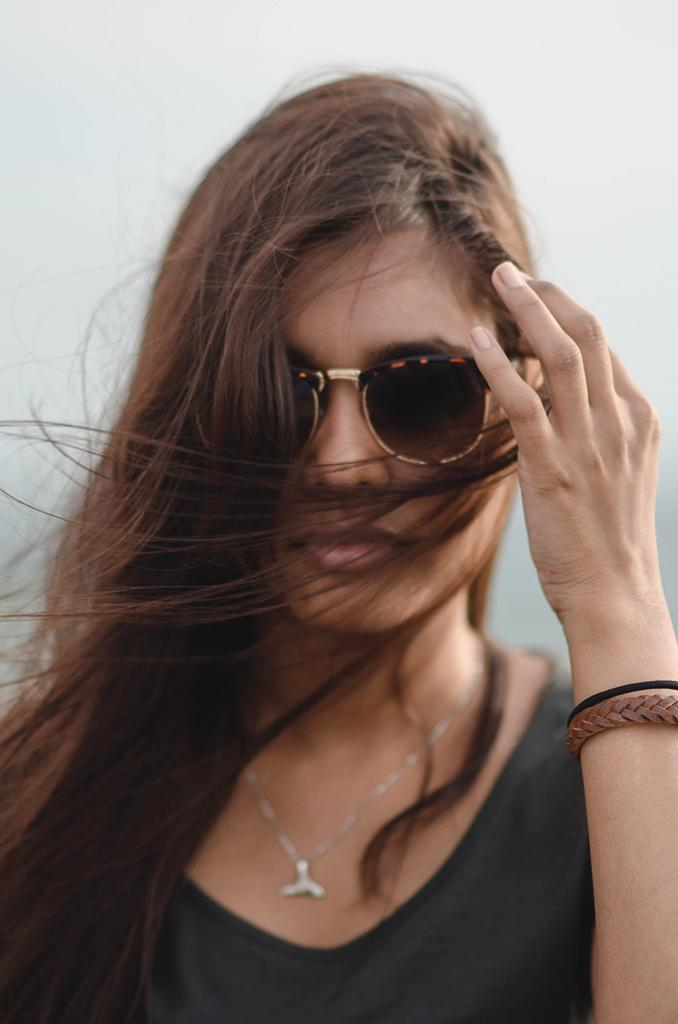Who is the main subject in the image? There is a woman in the image. What accessory is the woman wearing? The woman is wearing sunglasses. What is the color of the background in the image? The background of the image is white in color. Can you see any lawyers in the image? There is no mention of a lawyer in the image, so it cannot be determined if one is present. 